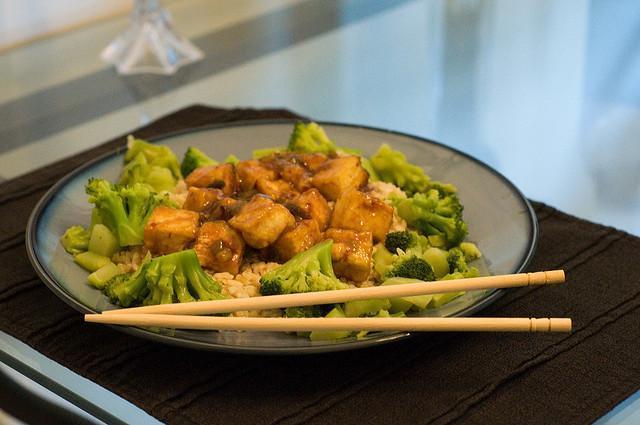How many broccolis are in the picture?
Give a very brief answer. 6. 